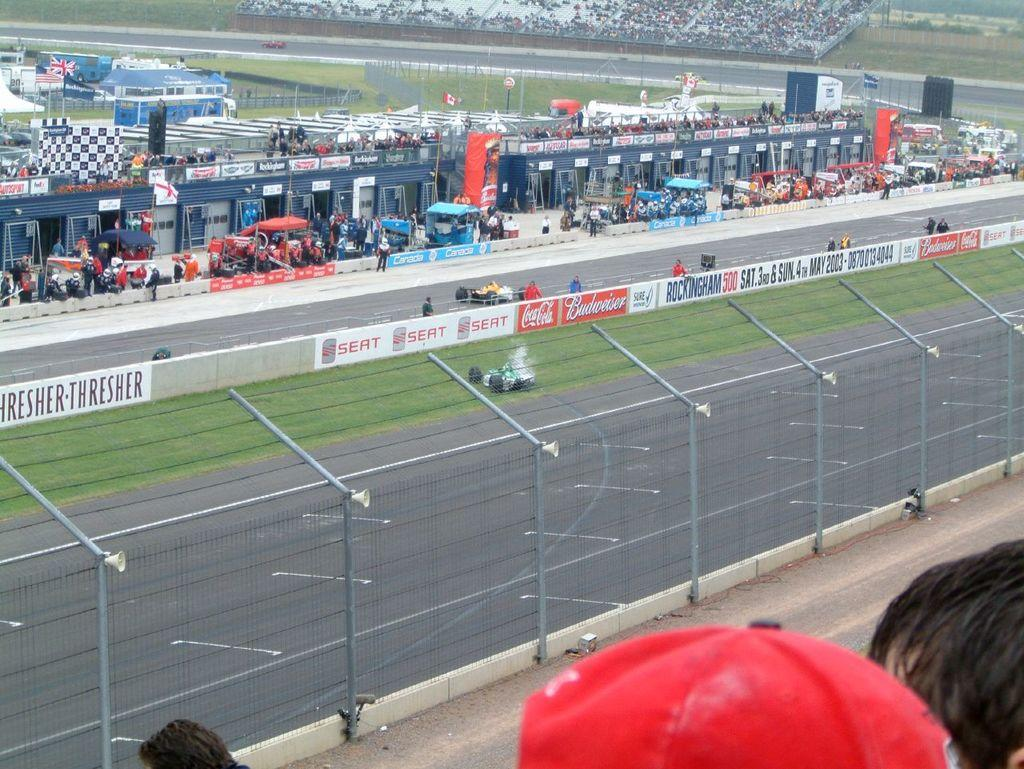How many people are in the image? There are persons in the image. What can be seen on the banners in the image? There are banners with text in the image. What type of surface is on the ground in the image? There is grass on the ground in the image. What type of vehicles are on the road in the image? There are cars on the road in the image. How many sisters are present in the image? There is no mention of sisters in the image, so we cannot determine the number of sisters present. What type of cast can be seen on the person's arm in the image? There is no mention of a cast or an injured person in the image. 